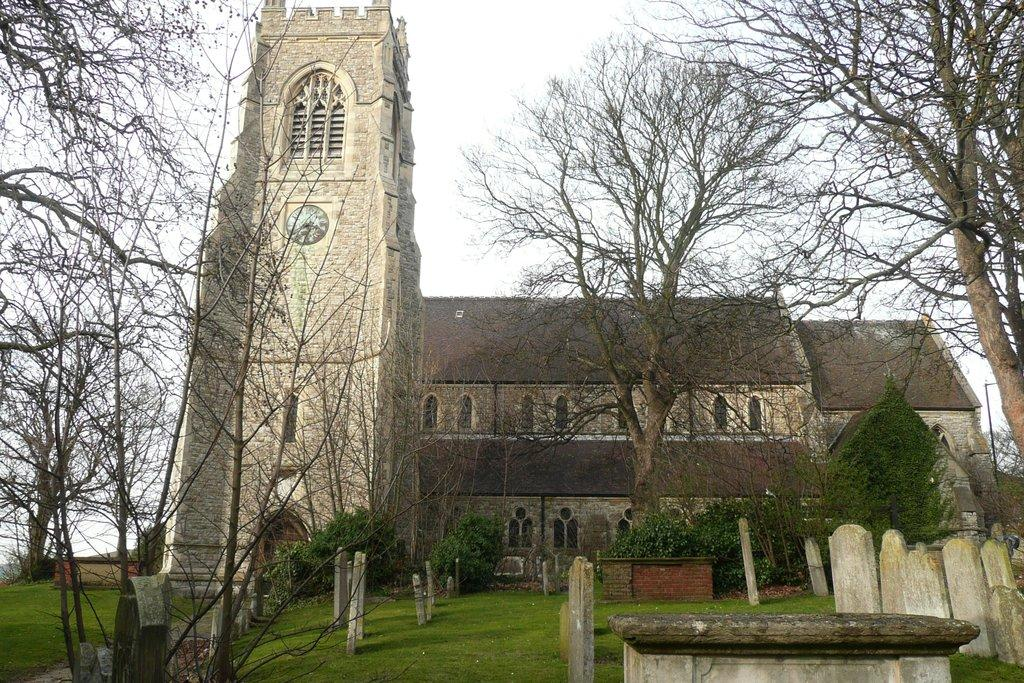What can be seen in the foreground of the picture? There are gravestones and trees in the foreground of the picture. What type of vegetation is present in the foreground of the picture? Plants are visible in the foreground of the picture. What is located in the center of the picture? There is a church and a clock in the center of the picture. What is the condition of the sky in the picture? The sky is cloudy in the picture. What time is indicated on the finger in the picture? There is no finger present in the picture; it features a clock on a church. How does the hot weather affect the plants in the image? The image does not indicate the weather conditions, but there is no mention of hot weather. 